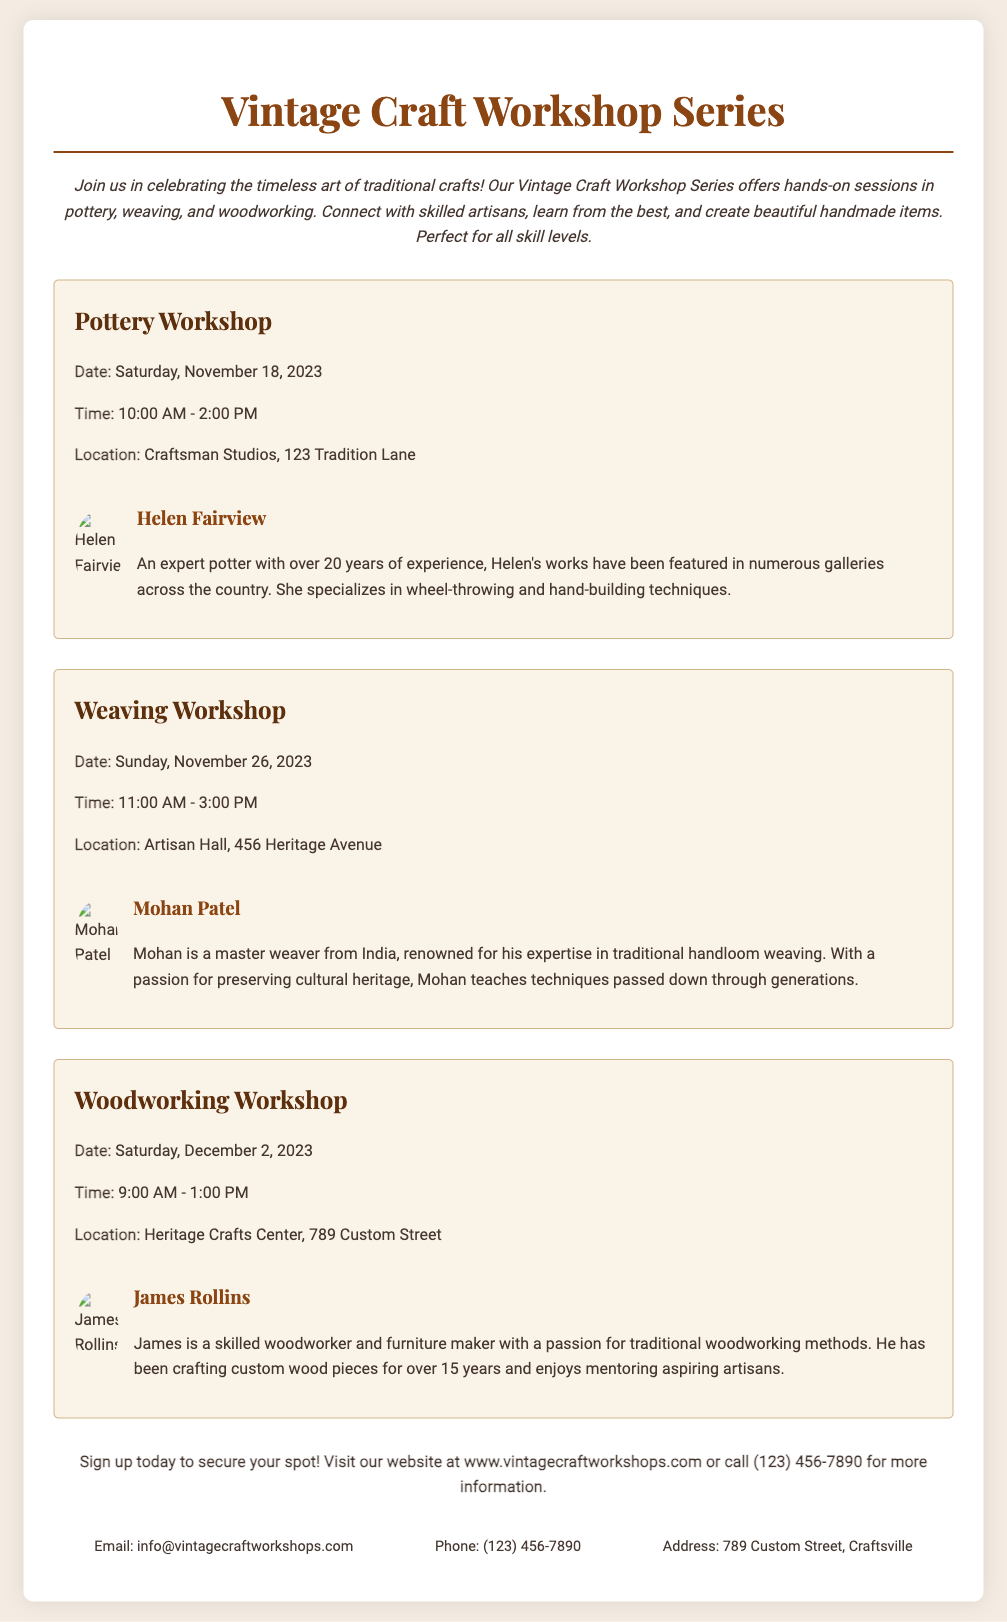What is the title of the workshop series? The title of the workshop series is prominently displayed at the top of the document.
Answer: Vintage Craft Workshop Series How many workshops are listed in the flyer? The flyer includes three distinct workshop listings.
Answer: Three Who is instructing the Pottery Workshop? The name of the instructor for the Pottery Workshop is mentioned in the corresponding section.
Answer: Helen Fairview What date is the Weaving Workshop scheduled for? The date is explicitly provided in the Weaving Workshop section.
Answer: Sunday, November 26, 2023 What location hosts the Woodworking Workshop? The location for the Woodworking Workshop is given in the workshop details.
Answer: Heritage Crafts Center, 789 Custom Street Which craft is taught by Mohan Patel? The craft instructor name is associated with a specific workshop listed in the document.
Answer: Weaving What is the time for the Pottery Workshop? The time is specifically stated in the details of the Pottery Workshop.
Answer: 10:00 AM - 2:00 PM What type of crafts are featured in the workshop series? The types of crafts are highlighted in the introductory paragraph of the document.
Answer: Pottery, weaving, and woodworking How can participants sign up for the workshops? The method for signing up is detailed in the footer section of the flyer.
Answer: Visit website or call What is the email contact provided in the flyer? The email contact is listed in the contact section of the document.
Answer: info@vintagecraftworkshops.com 